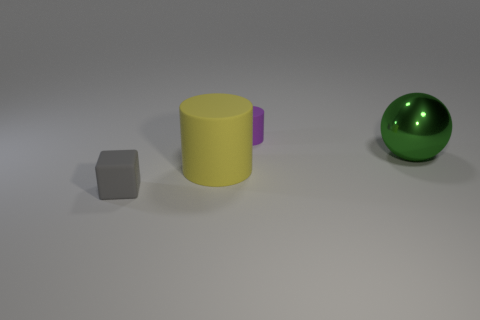Does the tiny thing that is behind the small matte cube have the same material as the object in front of the large matte cylinder?
Your response must be concise. Yes. How many objects are both in front of the large green shiny sphere and behind the small gray rubber object?
Provide a succinct answer. 1. Is there another purple rubber thing that has the same shape as the tiny purple matte thing?
Ensure brevity in your answer.  No. What shape is the purple matte object that is the same size as the gray matte thing?
Your response must be concise. Cylinder. Is the number of large metal spheres on the left side of the green metallic object the same as the number of small gray rubber objects that are behind the purple thing?
Keep it short and to the point. Yes. There is a matte cylinder that is in front of the tiny matte object that is on the right side of the small gray block; how big is it?
Offer a terse response. Large. Are there any cubes that have the same size as the yellow rubber cylinder?
Offer a very short reply. No. What color is the other large thing that is the same material as the gray object?
Offer a terse response. Yellow. Are there fewer red matte cubes than large green metal things?
Ensure brevity in your answer.  Yes. What material is the thing that is in front of the big sphere and behind the gray block?
Ensure brevity in your answer.  Rubber. 